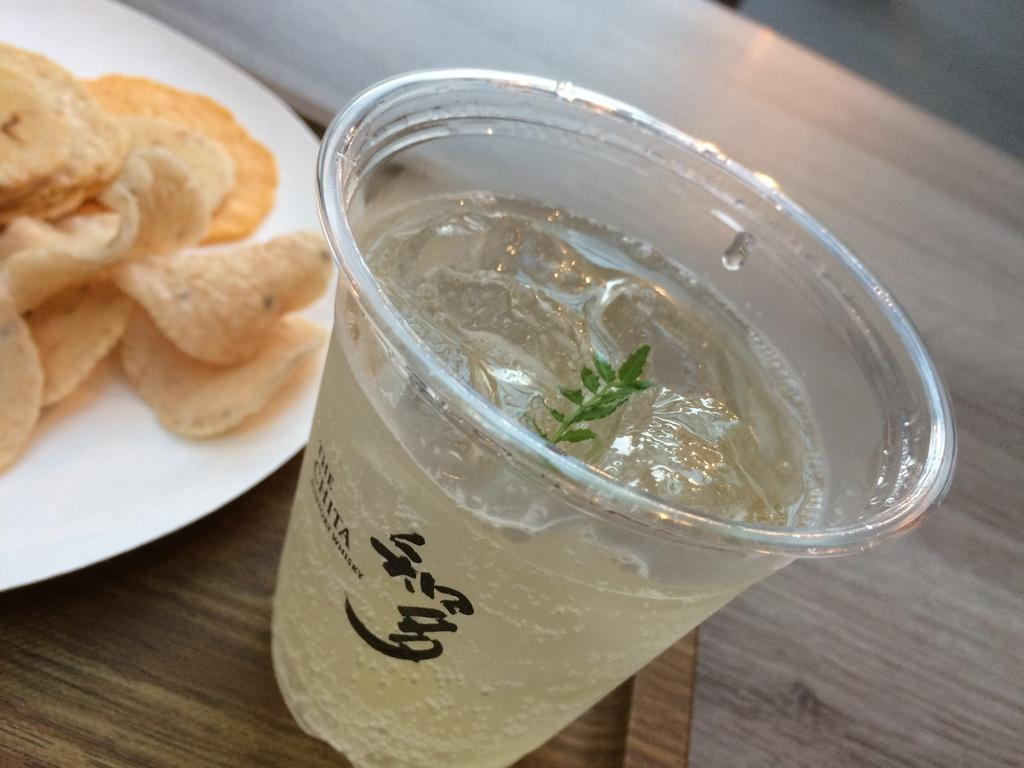What type of food is on the plate in the image? There are chips on a plate in the image. What beverage is in the glass in the image? There is juice in a glass in the image. What color is the plate in the image? The plate is brown. Where is the plate located in the image? The plate is on a big table. Can you see the bird's wing in the image? There is no bird or wing present in the image. How does the juice breathe in the glass? The juice does not breathe in the glass; it is a liquid and does not have the ability to breathe. 